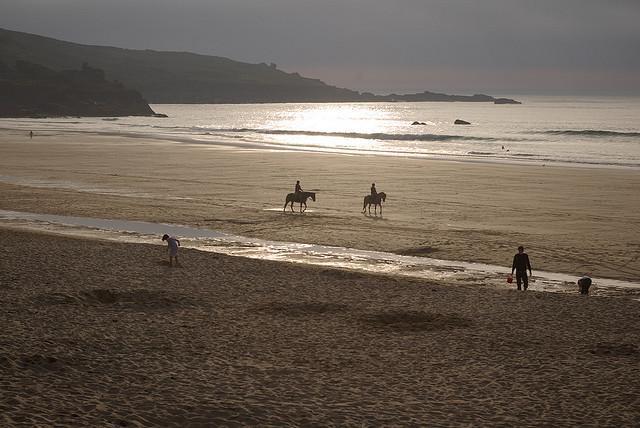How many cows are walking in the road?
Give a very brief answer. 0. 